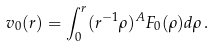<formula> <loc_0><loc_0><loc_500><loc_500>v _ { 0 } ( r ) = \int _ { 0 } ^ { r } ( r ^ { - 1 } \rho ) ^ { A } F _ { 0 } ( \rho ) d \rho \, .</formula> 